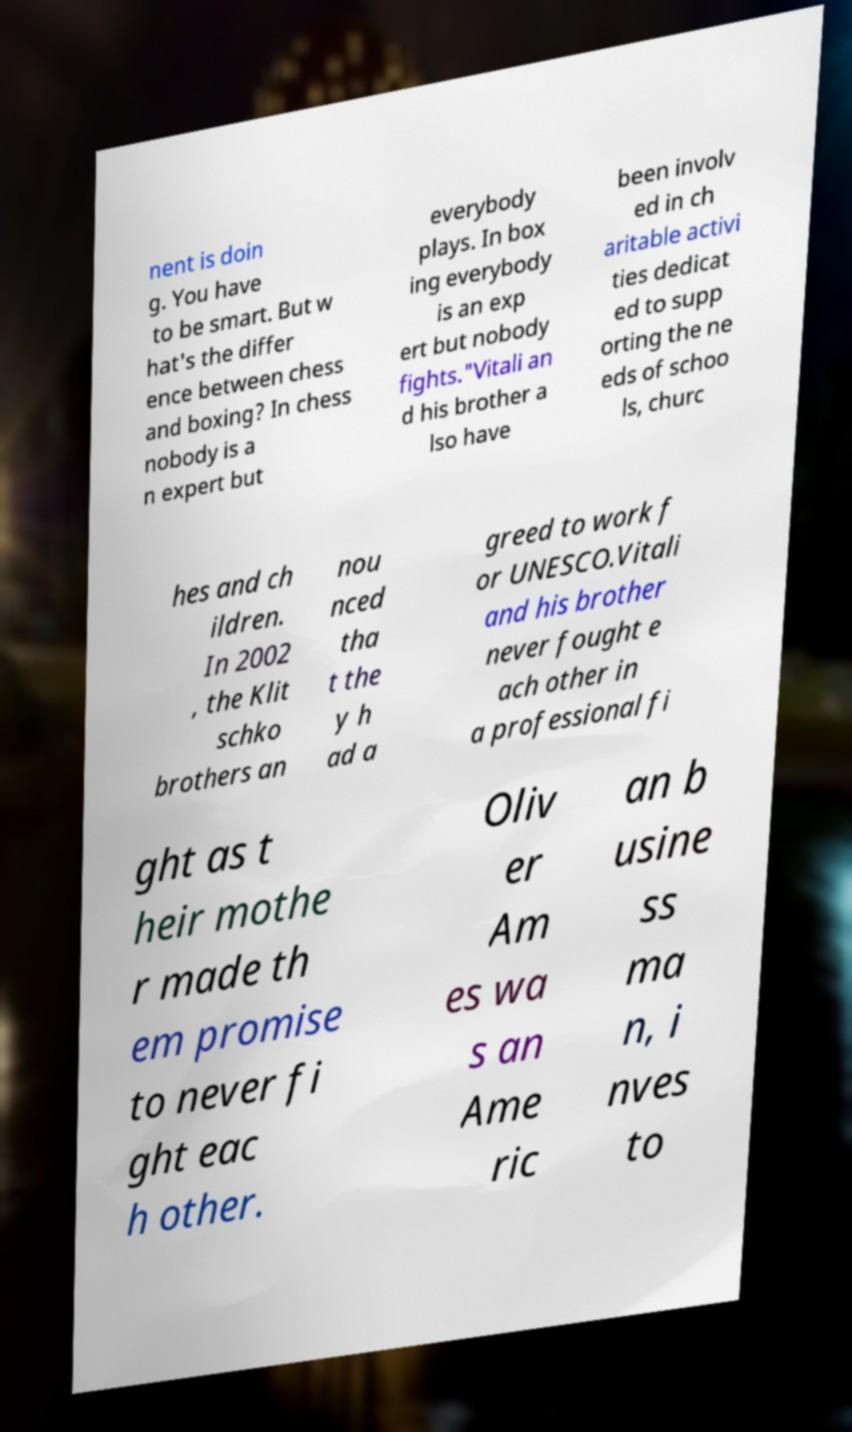Could you assist in decoding the text presented in this image and type it out clearly? nent is doin g. You have to be smart. But w hat's the differ ence between chess and boxing? In chess nobody is a n expert but everybody plays. In box ing everybody is an exp ert but nobody fights."Vitali an d his brother a lso have been involv ed in ch aritable activi ties dedicat ed to supp orting the ne eds of schoo ls, churc hes and ch ildren. In 2002 , the Klit schko brothers an nou nced tha t the y h ad a greed to work f or UNESCO.Vitali and his brother never fought e ach other in a professional fi ght as t heir mothe r made th em promise to never fi ght eac h other. Oliv er Am es wa s an Ame ric an b usine ss ma n, i nves to 